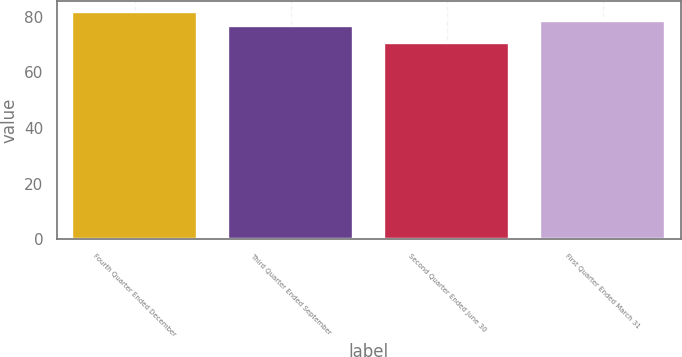Convert chart. <chart><loc_0><loc_0><loc_500><loc_500><bar_chart><fcel>Fourth Quarter Ended December<fcel>Third Quarter Ended September<fcel>Second Quarter Ended June 30<fcel>First Quarter Ended March 31<nl><fcel>81.59<fcel>76.76<fcel>70.61<fcel>78.49<nl></chart> 